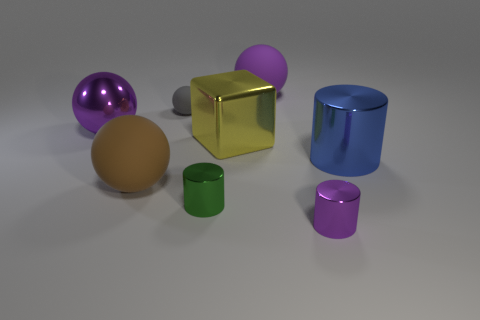Is there a big thing made of the same material as the small gray thing?
Make the answer very short. Yes. There is a metallic thing that is the same color as the metallic sphere; what shape is it?
Keep it short and to the point. Cylinder. What number of big things are there?
Offer a very short reply. 5. What number of balls are big purple rubber objects or large brown rubber objects?
Give a very brief answer. 2. What is the color of the block that is the same size as the blue cylinder?
Provide a short and direct response. Yellow. How many objects are to the right of the tiny purple cylinder and behind the large purple shiny ball?
Keep it short and to the point. 0. What is the large brown sphere made of?
Offer a terse response. Rubber. How many objects are matte balls or tiny yellow shiny balls?
Ensure brevity in your answer.  3. There is a purple ball behind the big shiny ball; does it have the same size as the shiny cylinder left of the purple cylinder?
Ensure brevity in your answer.  No. How many other objects are there of the same size as the shiny block?
Offer a terse response. 4. 